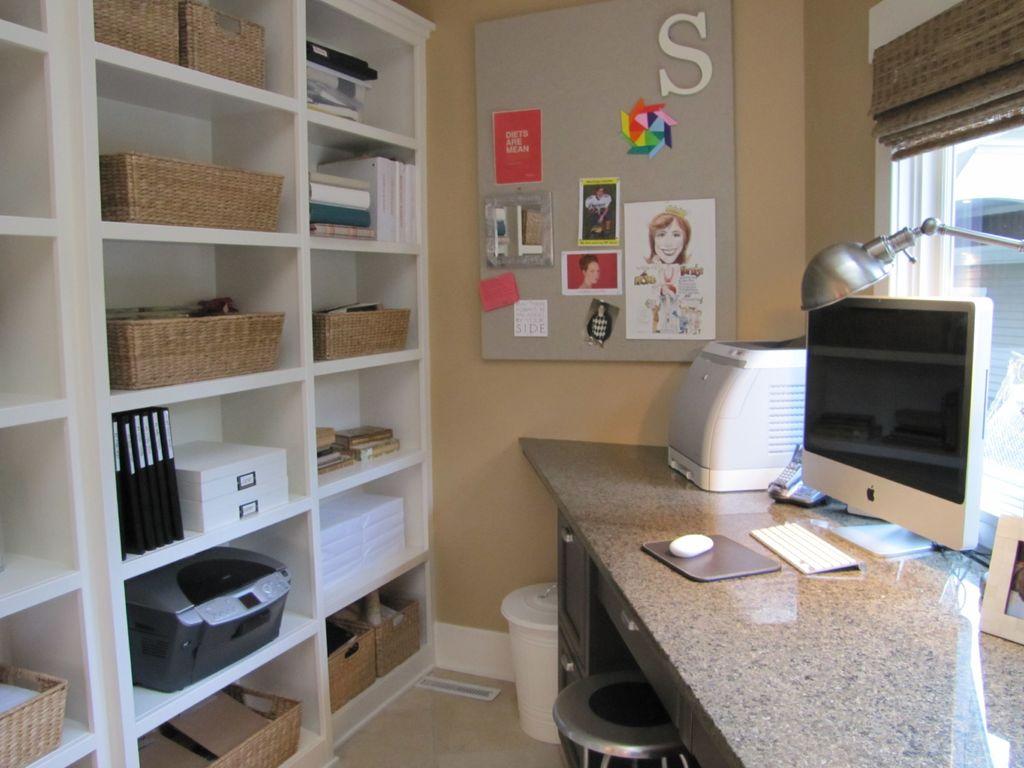What is the letter in white at the top?
Keep it short and to the point. S. 